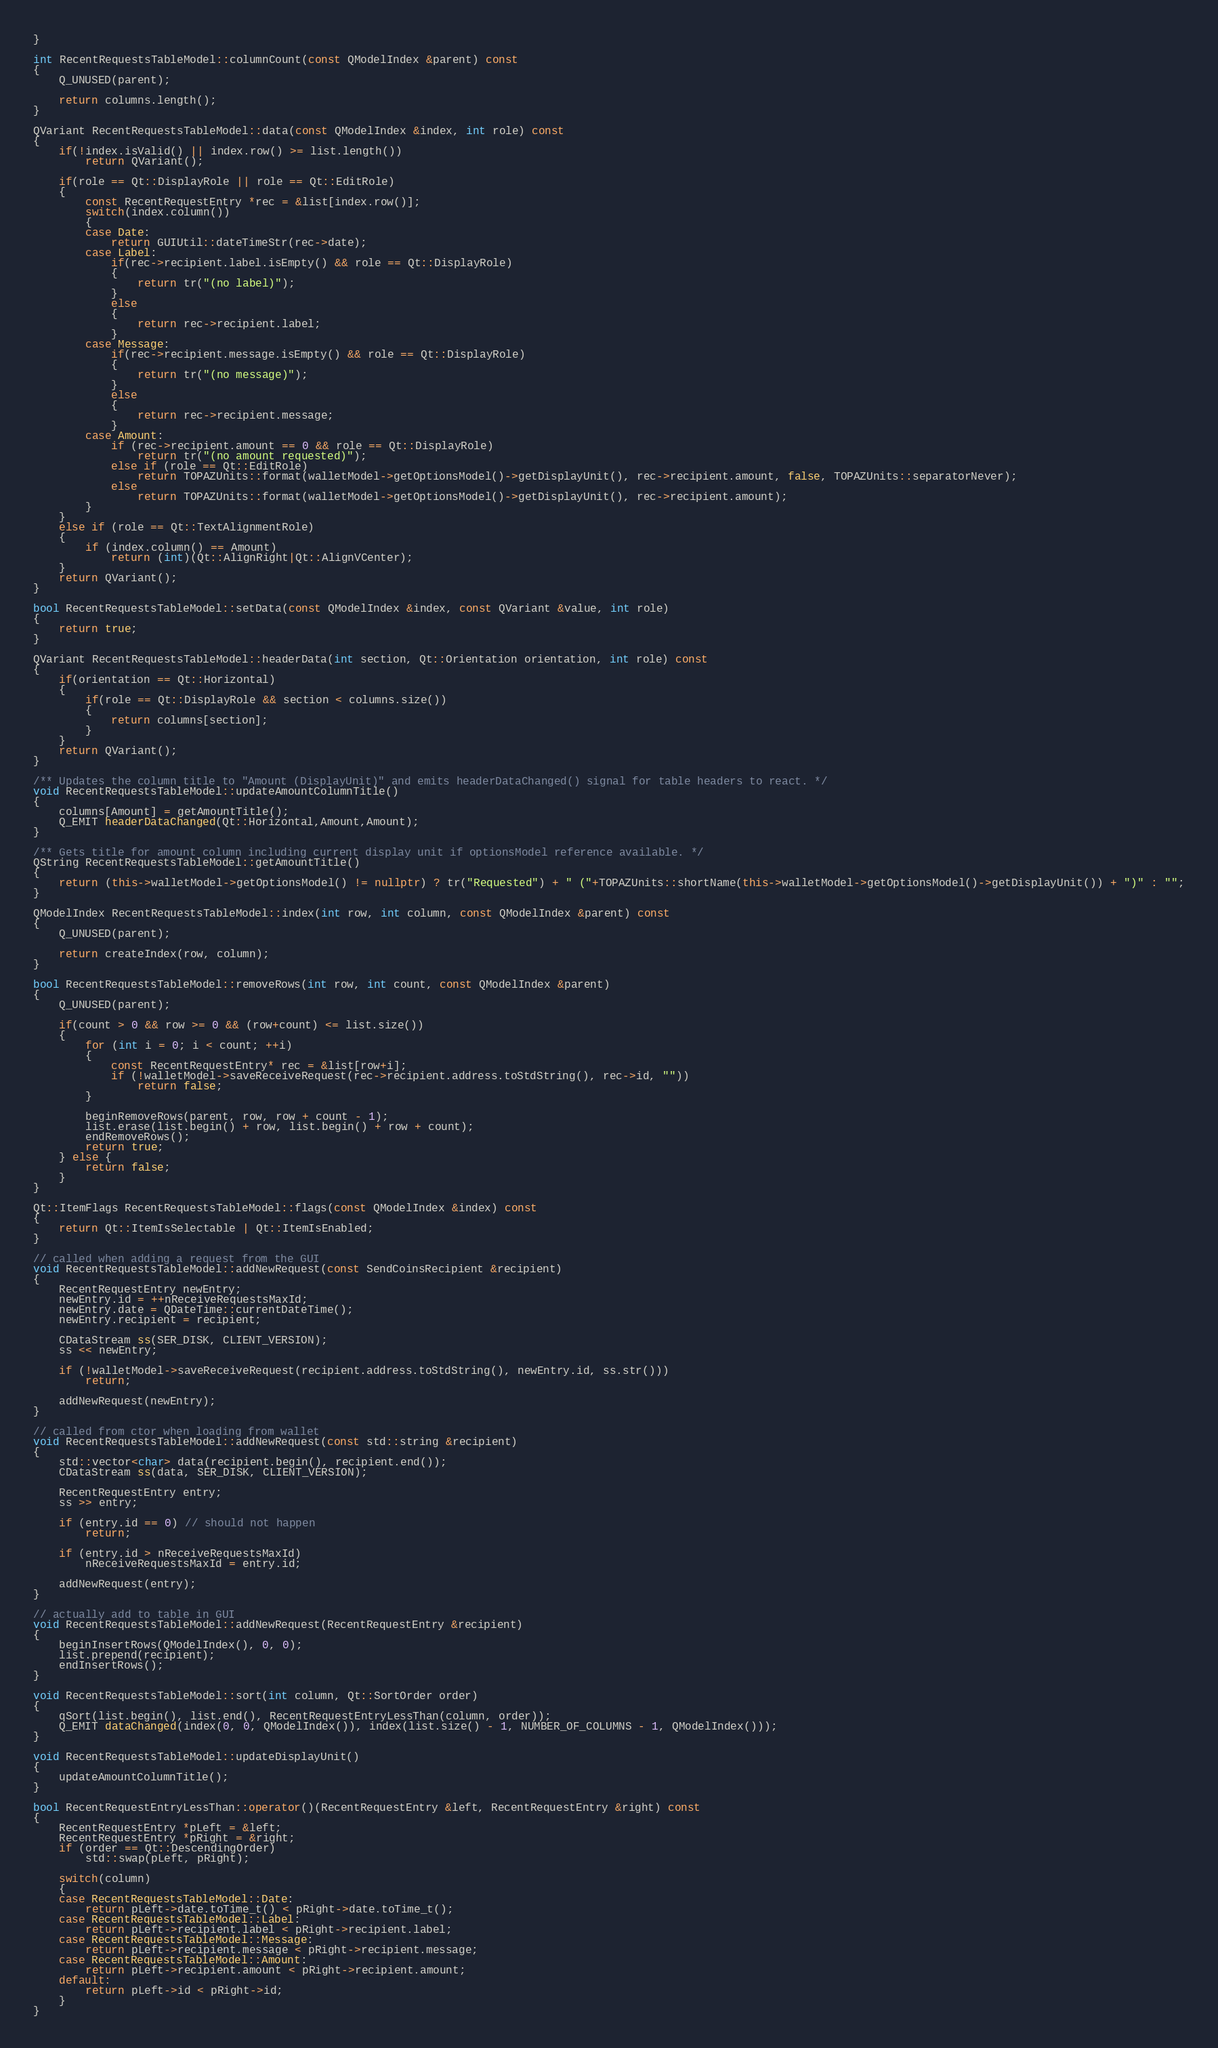Convert code to text. <code><loc_0><loc_0><loc_500><loc_500><_C++_>}

int RecentRequestsTableModel::columnCount(const QModelIndex &parent) const
{
    Q_UNUSED(parent);

    return columns.length();
}

QVariant RecentRequestsTableModel::data(const QModelIndex &index, int role) const
{
    if(!index.isValid() || index.row() >= list.length())
        return QVariant();

    if(role == Qt::DisplayRole || role == Qt::EditRole)
    {
        const RecentRequestEntry *rec = &list[index.row()];
        switch(index.column())
        {
        case Date:
            return GUIUtil::dateTimeStr(rec->date);
        case Label:
            if(rec->recipient.label.isEmpty() && role == Qt::DisplayRole)
            {
                return tr("(no label)");
            }
            else
            {
                return rec->recipient.label;
            }
        case Message:
            if(rec->recipient.message.isEmpty() && role == Qt::DisplayRole)
            {
                return tr("(no message)");
            }
            else
            {
                return rec->recipient.message;
            }
        case Amount:
            if (rec->recipient.amount == 0 && role == Qt::DisplayRole)
                return tr("(no amount requested)");
            else if (role == Qt::EditRole)
                return TOPAZUnits::format(walletModel->getOptionsModel()->getDisplayUnit(), rec->recipient.amount, false, TOPAZUnits::separatorNever);
            else
                return TOPAZUnits::format(walletModel->getOptionsModel()->getDisplayUnit(), rec->recipient.amount);
        }
    }
    else if (role == Qt::TextAlignmentRole)
    {
        if (index.column() == Amount)
            return (int)(Qt::AlignRight|Qt::AlignVCenter);
    }
    return QVariant();
}

bool RecentRequestsTableModel::setData(const QModelIndex &index, const QVariant &value, int role)
{
    return true;
}

QVariant RecentRequestsTableModel::headerData(int section, Qt::Orientation orientation, int role) const
{
    if(orientation == Qt::Horizontal)
    {
        if(role == Qt::DisplayRole && section < columns.size())
        {
            return columns[section];
        }
    }
    return QVariant();
}

/** Updates the column title to "Amount (DisplayUnit)" and emits headerDataChanged() signal for table headers to react. */
void RecentRequestsTableModel::updateAmountColumnTitle()
{
    columns[Amount] = getAmountTitle();
    Q_EMIT headerDataChanged(Qt::Horizontal,Amount,Amount);
}

/** Gets title for amount column including current display unit if optionsModel reference available. */
QString RecentRequestsTableModel::getAmountTitle()
{
    return (this->walletModel->getOptionsModel() != nullptr) ? tr("Requested") + " ("+TOPAZUnits::shortName(this->walletModel->getOptionsModel()->getDisplayUnit()) + ")" : "";
}

QModelIndex RecentRequestsTableModel::index(int row, int column, const QModelIndex &parent) const
{
    Q_UNUSED(parent);

    return createIndex(row, column);
}

bool RecentRequestsTableModel::removeRows(int row, int count, const QModelIndex &parent)
{
    Q_UNUSED(parent);

    if(count > 0 && row >= 0 && (row+count) <= list.size())
    {
        for (int i = 0; i < count; ++i)
        {
            const RecentRequestEntry* rec = &list[row+i];
            if (!walletModel->saveReceiveRequest(rec->recipient.address.toStdString(), rec->id, ""))
                return false;
        }

        beginRemoveRows(parent, row, row + count - 1);
        list.erase(list.begin() + row, list.begin() + row + count);
        endRemoveRows();
        return true;
    } else {
        return false;
    }
}

Qt::ItemFlags RecentRequestsTableModel::flags(const QModelIndex &index) const
{
    return Qt::ItemIsSelectable | Qt::ItemIsEnabled;
}

// called when adding a request from the GUI
void RecentRequestsTableModel::addNewRequest(const SendCoinsRecipient &recipient)
{
    RecentRequestEntry newEntry;
    newEntry.id = ++nReceiveRequestsMaxId;
    newEntry.date = QDateTime::currentDateTime();
    newEntry.recipient = recipient;

    CDataStream ss(SER_DISK, CLIENT_VERSION);
    ss << newEntry;

    if (!walletModel->saveReceiveRequest(recipient.address.toStdString(), newEntry.id, ss.str()))
        return;

    addNewRequest(newEntry);
}

// called from ctor when loading from wallet
void RecentRequestsTableModel::addNewRequest(const std::string &recipient)
{
    std::vector<char> data(recipient.begin(), recipient.end());
    CDataStream ss(data, SER_DISK, CLIENT_VERSION);

    RecentRequestEntry entry;
    ss >> entry;

    if (entry.id == 0) // should not happen
        return;

    if (entry.id > nReceiveRequestsMaxId)
        nReceiveRequestsMaxId = entry.id;

    addNewRequest(entry);
}

// actually add to table in GUI
void RecentRequestsTableModel::addNewRequest(RecentRequestEntry &recipient)
{
    beginInsertRows(QModelIndex(), 0, 0);
    list.prepend(recipient);
    endInsertRows();
}

void RecentRequestsTableModel::sort(int column, Qt::SortOrder order)
{
    qSort(list.begin(), list.end(), RecentRequestEntryLessThan(column, order));
    Q_EMIT dataChanged(index(0, 0, QModelIndex()), index(list.size() - 1, NUMBER_OF_COLUMNS - 1, QModelIndex()));
}

void RecentRequestsTableModel::updateDisplayUnit()
{
    updateAmountColumnTitle();
}

bool RecentRequestEntryLessThan::operator()(RecentRequestEntry &left, RecentRequestEntry &right) const
{
    RecentRequestEntry *pLeft = &left;
    RecentRequestEntry *pRight = &right;
    if (order == Qt::DescendingOrder)
        std::swap(pLeft, pRight);

    switch(column)
    {
    case RecentRequestsTableModel::Date:
        return pLeft->date.toTime_t() < pRight->date.toTime_t();
    case RecentRequestsTableModel::Label:
        return pLeft->recipient.label < pRight->recipient.label;
    case RecentRequestsTableModel::Message:
        return pLeft->recipient.message < pRight->recipient.message;
    case RecentRequestsTableModel::Amount:
        return pLeft->recipient.amount < pRight->recipient.amount;
    default:
        return pLeft->id < pRight->id;
    }
}
</code> 